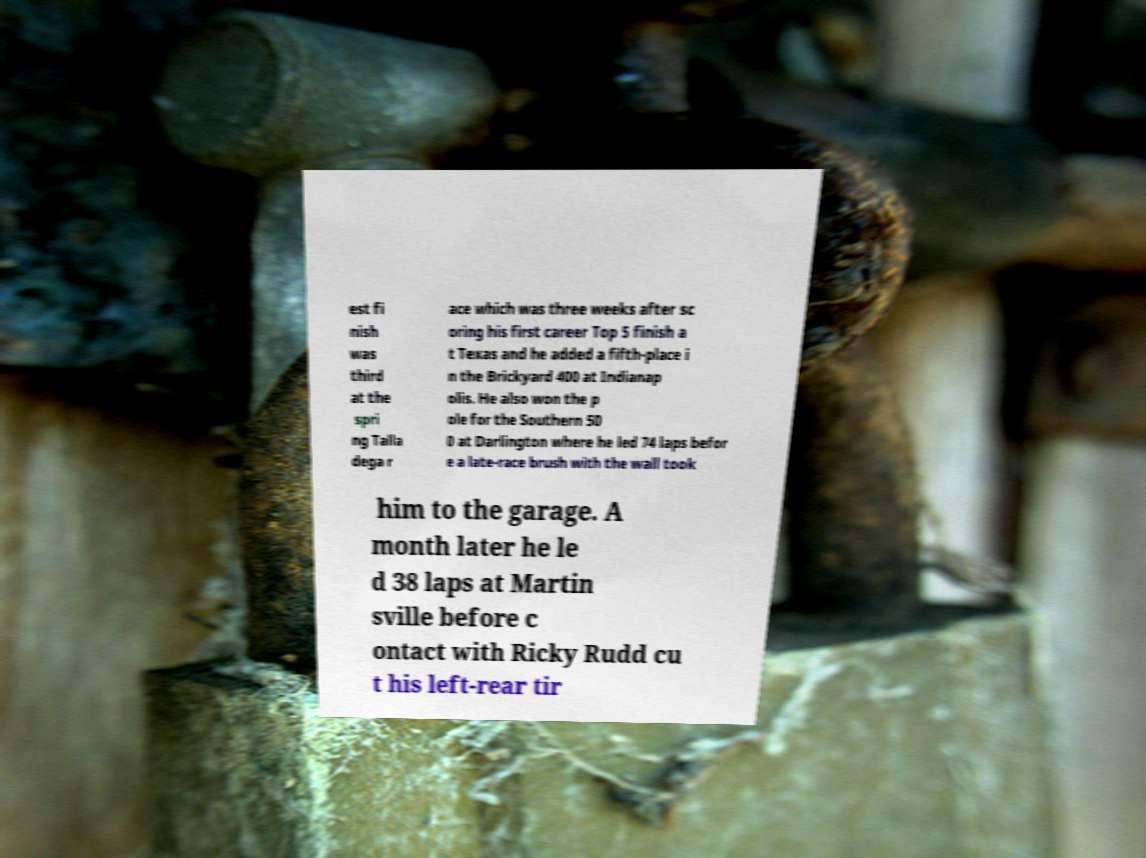Please identify and transcribe the text found in this image. est fi nish was third at the spri ng Talla dega r ace which was three weeks after sc oring his first career Top 5 finish a t Texas and he added a fifth-place i n the Brickyard 400 at Indianap olis. He also won the p ole for the Southern 50 0 at Darlington where he led 74 laps befor e a late-race brush with the wall took him to the garage. A month later he le d 38 laps at Martin sville before c ontact with Ricky Rudd cu t his left-rear tir 